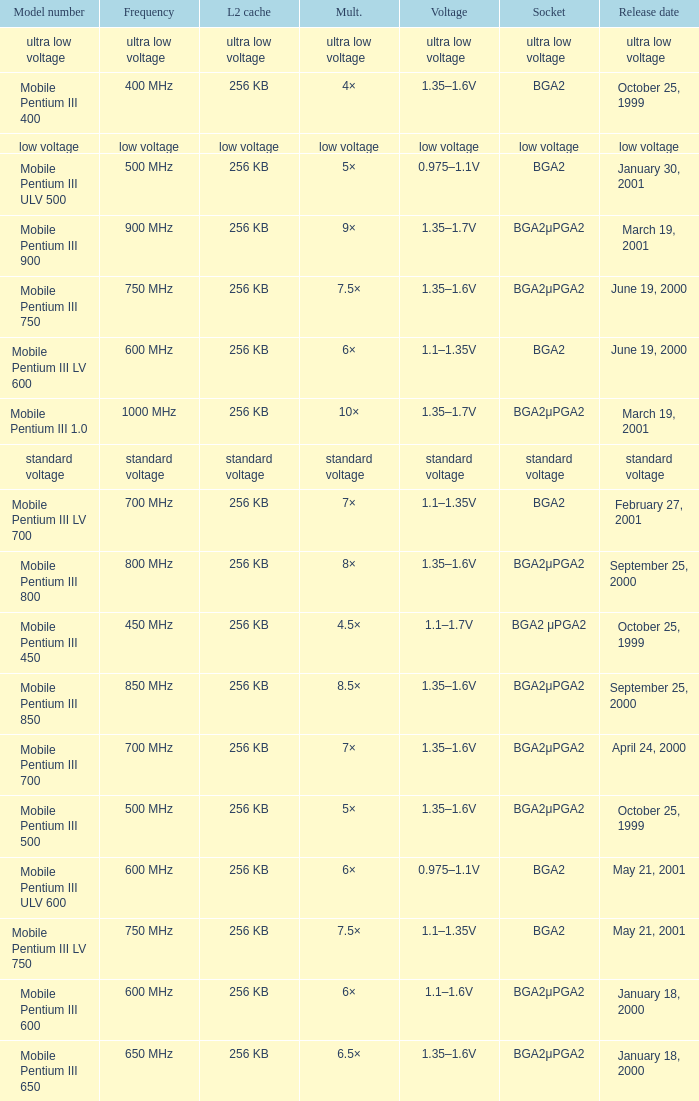Which model has a frequency of 750 mhz and a socket of bga2μpga2? Mobile Pentium III 750. 